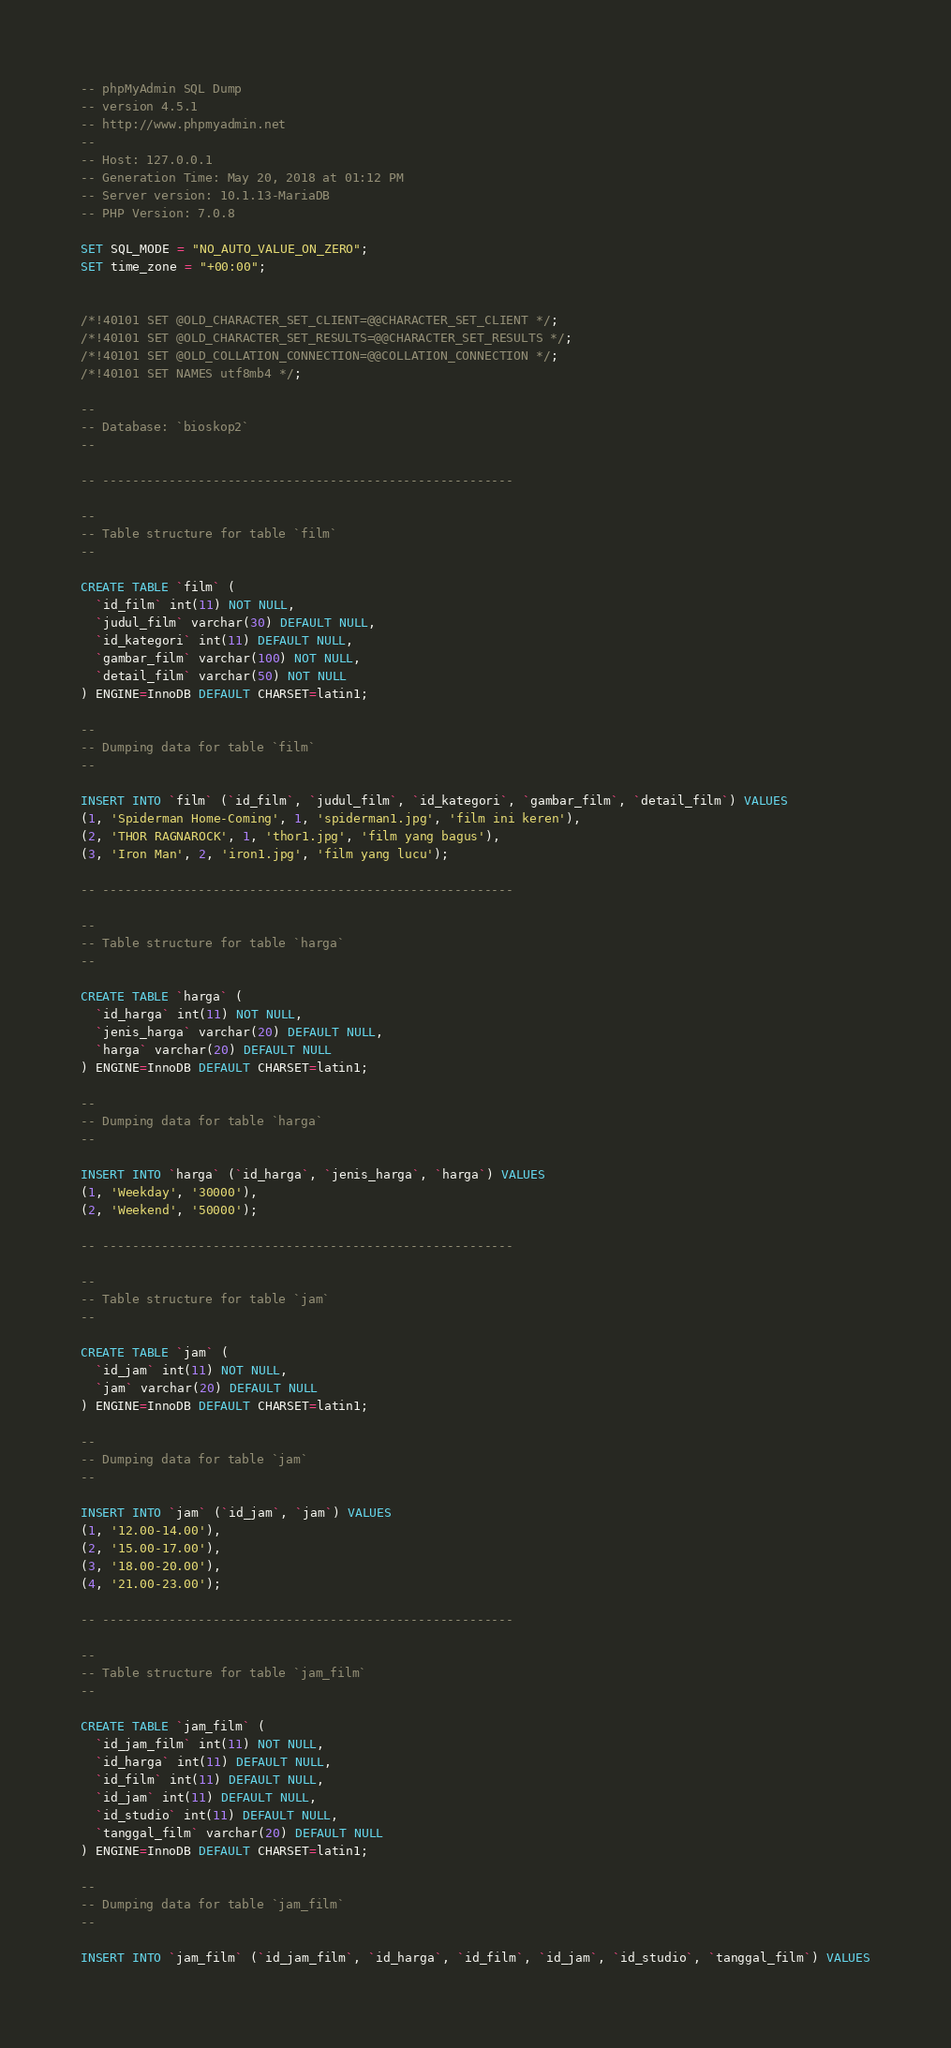Convert code to text. <code><loc_0><loc_0><loc_500><loc_500><_SQL_>-- phpMyAdmin SQL Dump
-- version 4.5.1
-- http://www.phpmyadmin.net
--
-- Host: 127.0.0.1
-- Generation Time: May 20, 2018 at 01:12 PM
-- Server version: 10.1.13-MariaDB
-- PHP Version: 7.0.8

SET SQL_MODE = "NO_AUTO_VALUE_ON_ZERO";
SET time_zone = "+00:00";


/*!40101 SET @OLD_CHARACTER_SET_CLIENT=@@CHARACTER_SET_CLIENT */;
/*!40101 SET @OLD_CHARACTER_SET_RESULTS=@@CHARACTER_SET_RESULTS */;
/*!40101 SET @OLD_COLLATION_CONNECTION=@@COLLATION_CONNECTION */;
/*!40101 SET NAMES utf8mb4 */;

--
-- Database: `bioskop2`
--

-- --------------------------------------------------------

--
-- Table structure for table `film`
--

CREATE TABLE `film` (
  `id_film` int(11) NOT NULL,
  `judul_film` varchar(30) DEFAULT NULL,
  `id_kategori` int(11) DEFAULT NULL,
  `gambar_film` varchar(100) NOT NULL,
  `detail_film` varchar(50) NOT NULL
) ENGINE=InnoDB DEFAULT CHARSET=latin1;

--
-- Dumping data for table `film`
--

INSERT INTO `film` (`id_film`, `judul_film`, `id_kategori`, `gambar_film`, `detail_film`) VALUES
(1, 'Spiderman Home-Coming', 1, 'spiderman1.jpg', 'film ini keren'),
(2, 'THOR RAGNAROCK', 1, 'thor1.jpg', 'film yang bagus'),
(3, 'Iron Man', 2, 'iron1.jpg', 'film yang lucu');

-- --------------------------------------------------------

--
-- Table structure for table `harga`
--

CREATE TABLE `harga` (
  `id_harga` int(11) NOT NULL,
  `jenis_harga` varchar(20) DEFAULT NULL,
  `harga` varchar(20) DEFAULT NULL
) ENGINE=InnoDB DEFAULT CHARSET=latin1;

--
-- Dumping data for table `harga`
--

INSERT INTO `harga` (`id_harga`, `jenis_harga`, `harga`) VALUES
(1, 'Weekday', '30000'),
(2, 'Weekend', '50000');

-- --------------------------------------------------------

--
-- Table structure for table `jam`
--

CREATE TABLE `jam` (
  `id_jam` int(11) NOT NULL,
  `jam` varchar(20) DEFAULT NULL
) ENGINE=InnoDB DEFAULT CHARSET=latin1;

--
-- Dumping data for table `jam`
--

INSERT INTO `jam` (`id_jam`, `jam`) VALUES
(1, '12.00-14.00'),
(2, '15.00-17.00'),
(3, '18.00-20.00'),
(4, '21.00-23.00');

-- --------------------------------------------------------

--
-- Table structure for table `jam_film`
--

CREATE TABLE `jam_film` (
  `id_jam_film` int(11) NOT NULL,
  `id_harga` int(11) DEFAULT NULL,
  `id_film` int(11) DEFAULT NULL,
  `id_jam` int(11) DEFAULT NULL,
  `id_studio` int(11) DEFAULT NULL,
  `tanggal_film` varchar(20) DEFAULT NULL
) ENGINE=InnoDB DEFAULT CHARSET=latin1;

--
-- Dumping data for table `jam_film`
--

INSERT INTO `jam_film` (`id_jam_film`, `id_harga`, `id_film`, `id_jam`, `id_studio`, `tanggal_film`) VALUES</code> 